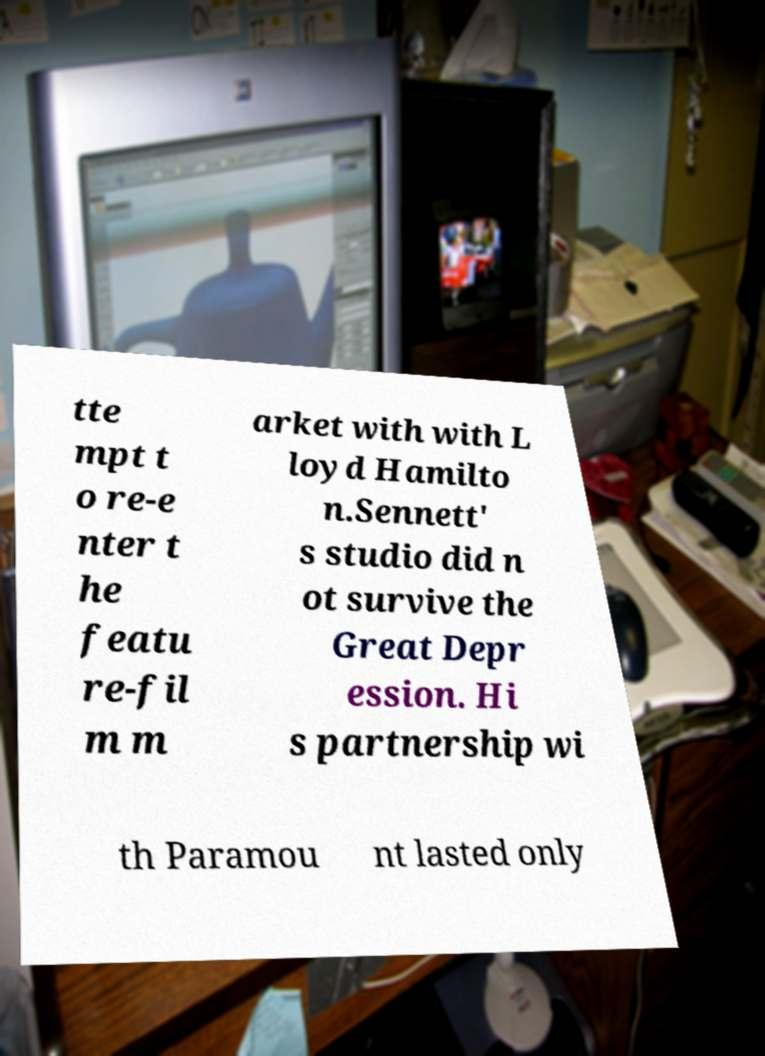I need the written content from this picture converted into text. Can you do that? tte mpt t o re-e nter t he featu re-fil m m arket with with L loyd Hamilto n.Sennett' s studio did n ot survive the Great Depr ession. Hi s partnership wi th Paramou nt lasted only 